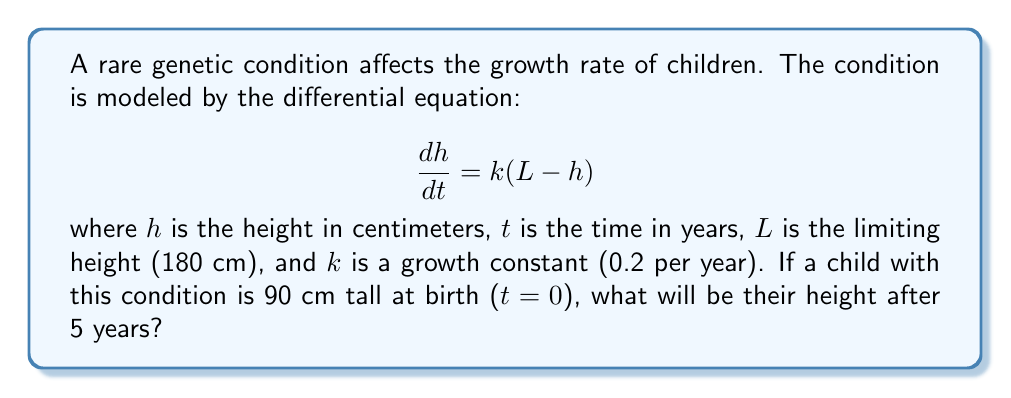Could you help me with this problem? To solve this problem, we need to use the solution to the given differential equation, which is a first-order linear differential equation.

1) The general solution to this equation is:

   $$h(t) = L - (L - h_0)e^{-kt}$$

   where $h_0$ is the initial height.

2) We are given the following values:
   - $L = 180$ cm (limiting height)
   - $k = 0.2$ per year (growth constant)
   - $h_0 = 90$ cm (height at birth)
   - $t = 5$ years (time we're interested in)

3) Let's substitute these values into our equation:

   $$h(5) = 180 - (180 - 90)e^{-0.2(5)}$$

4) Simplify:
   $$h(5) = 180 - 90e^{-1}$$

5) Calculate $e^{-1}$:
   $$e^{-1} \approx 0.3679$$

6) Substitute this value:
   $$h(5) = 180 - 90(0.3679)$$
   $$h(5) = 180 - 33.111$$
   $$h(5) = 146.889$$

7) Round to the nearest centimeter:
   $$h(5) \approx 147 \text{ cm}$$

Therefore, after 5 years, the child will be approximately 147 cm tall.
Answer: 147 cm 